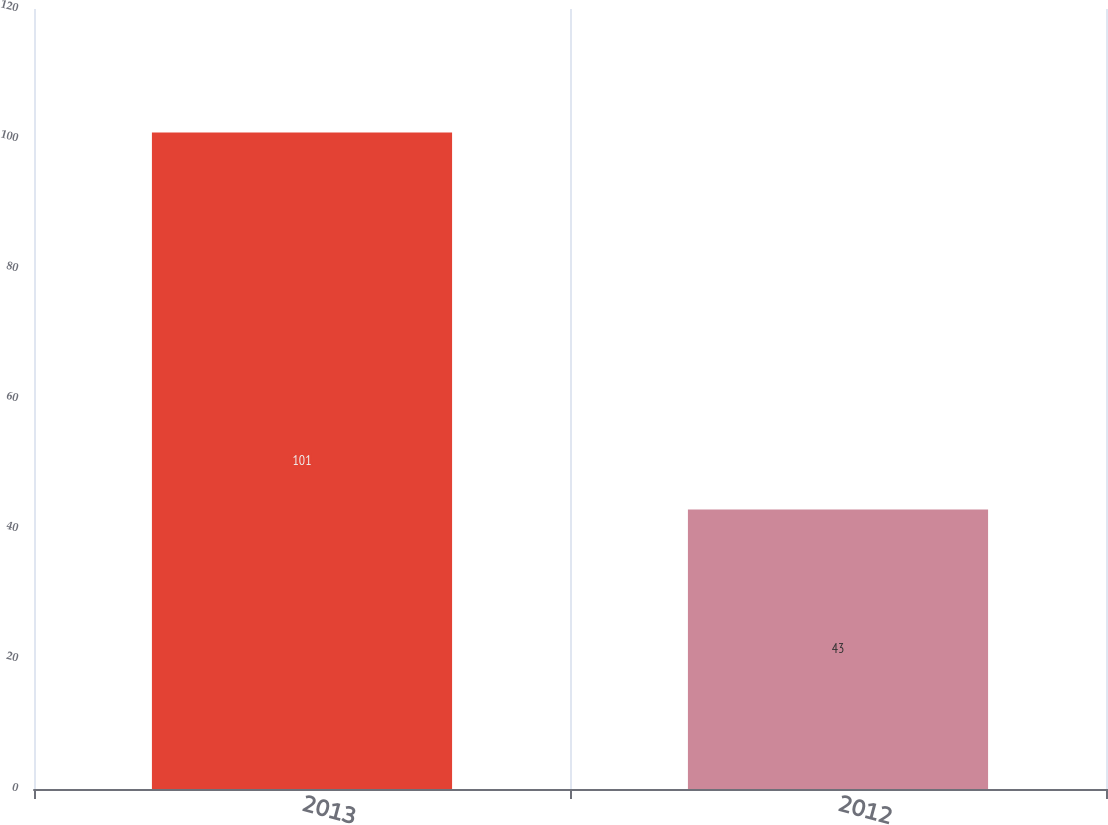Convert chart to OTSL. <chart><loc_0><loc_0><loc_500><loc_500><bar_chart><fcel>2013<fcel>2012<nl><fcel>101<fcel>43<nl></chart> 